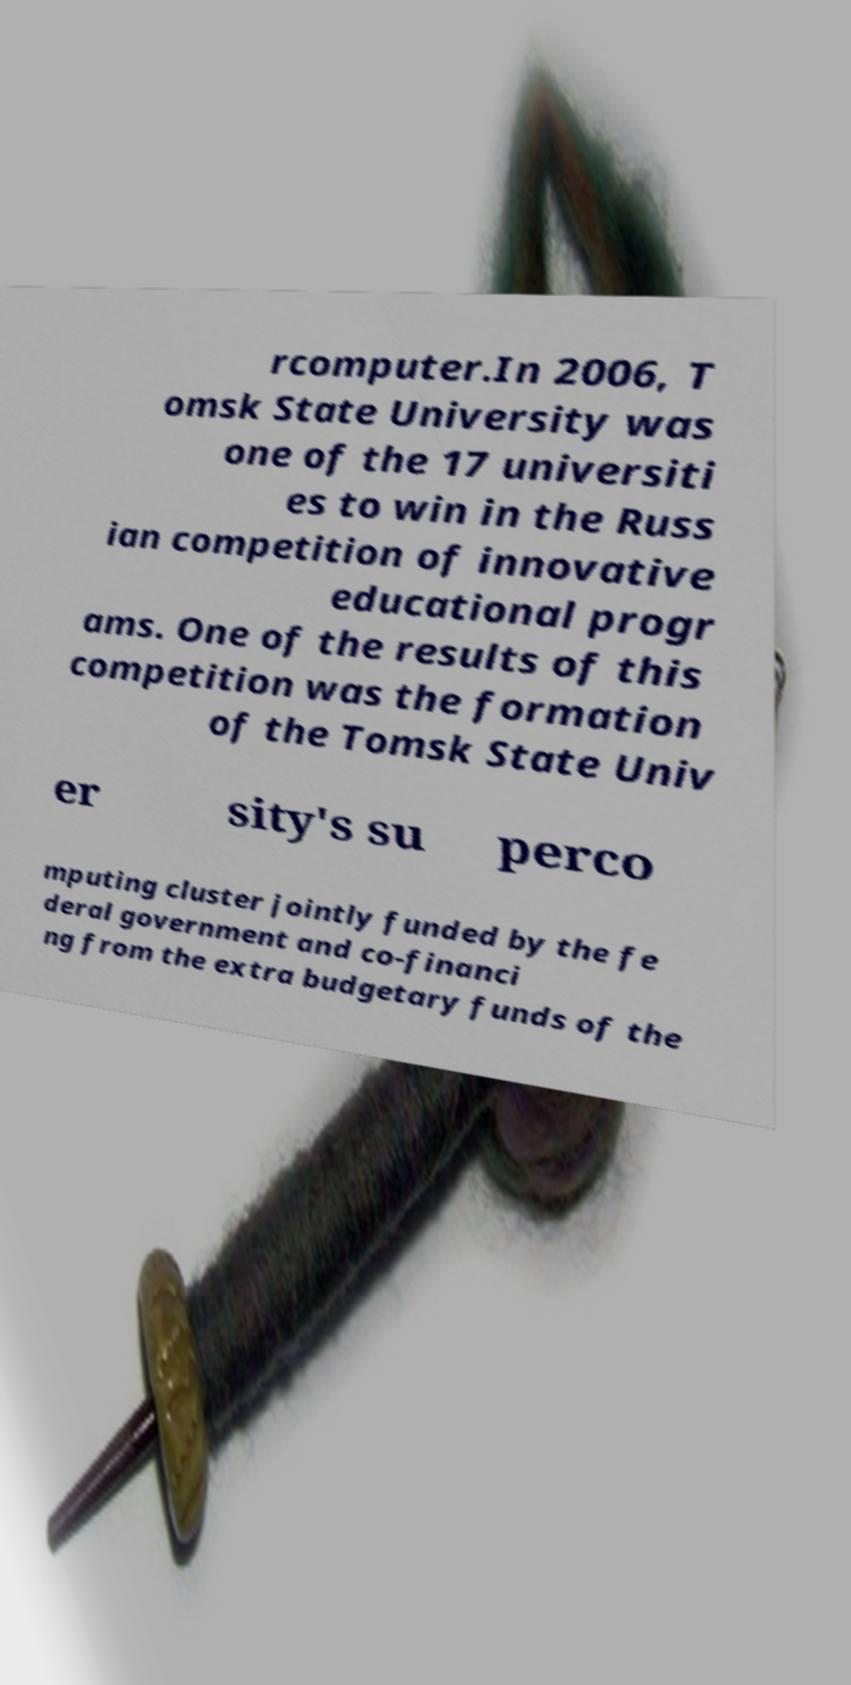Please identify and transcribe the text found in this image. rcomputer.In 2006, T omsk State University was one of the 17 universiti es to win in the Russ ian competition of innovative educational progr ams. One of the results of this competition was the formation of the Tomsk State Univ er sity's su perco mputing cluster jointly funded by the fe deral government and co-financi ng from the extra budgetary funds of the 